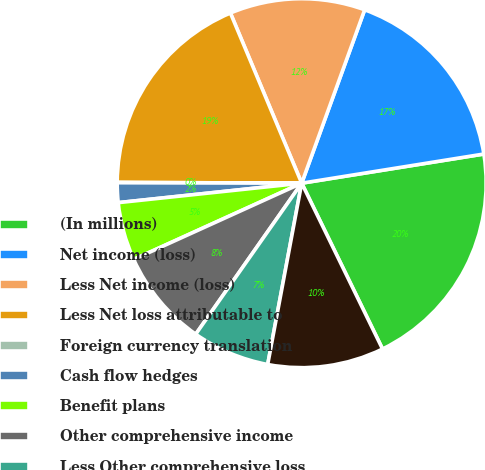Convert chart. <chart><loc_0><loc_0><loc_500><loc_500><pie_chart><fcel>(In millions)<fcel>Net income (loss)<fcel>Less Net income (loss)<fcel>Less Net loss attributable to<fcel>Foreign currency translation<fcel>Cash flow hedges<fcel>Benefit plans<fcel>Other comprehensive income<fcel>Less Other comprehensive loss<fcel>Less Other comprehensive<nl><fcel>20.31%<fcel>16.93%<fcel>11.86%<fcel>18.62%<fcel>0.03%<fcel>1.72%<fcel>5.1%<fcel>8.48%<fcel>6.79%<fcel>10.17%<nl></chart> 